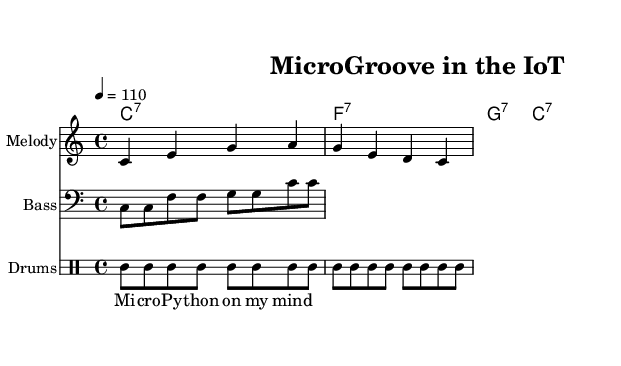What is the key signature of this music? The key signature is C major, which has no sharps or flats.
Answer: C major What is the time signature of this music? The time signature is indicated right after the key signature and is 4/4, which means there are four beats per measure.
Answer: 4/4 What is the tempo marking for the piece? The tempo marking is shown as "4 = 110," which indicates that there are 110 beats per minute in a quarter note.
Answer: 110 How many notes are played in the melody of the piece? The melody consists of a series of notes that can be counted in the 'melody' section. There are eight distinct pitches in the melody line.
Answer: 8 What type of chord progression is used in this piece? The chord progression is identified in the 'harmonies' section, showing chords from the 7th family (C7, F7, G7). This reflects a common progression in funk music.
Answer: 7th chords Which instrument plays the bass line? The 'bassLine' is indicated to be played in the bass clef, which is commonly associated with the bass instrument, reinforcing the role of bass in funk music.
Answer: Bass What is the theme of the lyrics in this music? The lyrics suggest a focus on "MicroPython," a programming language relevant to microcontrollers, hence relating to IoT and technology themes in the piece.
Answer: MicroPython 